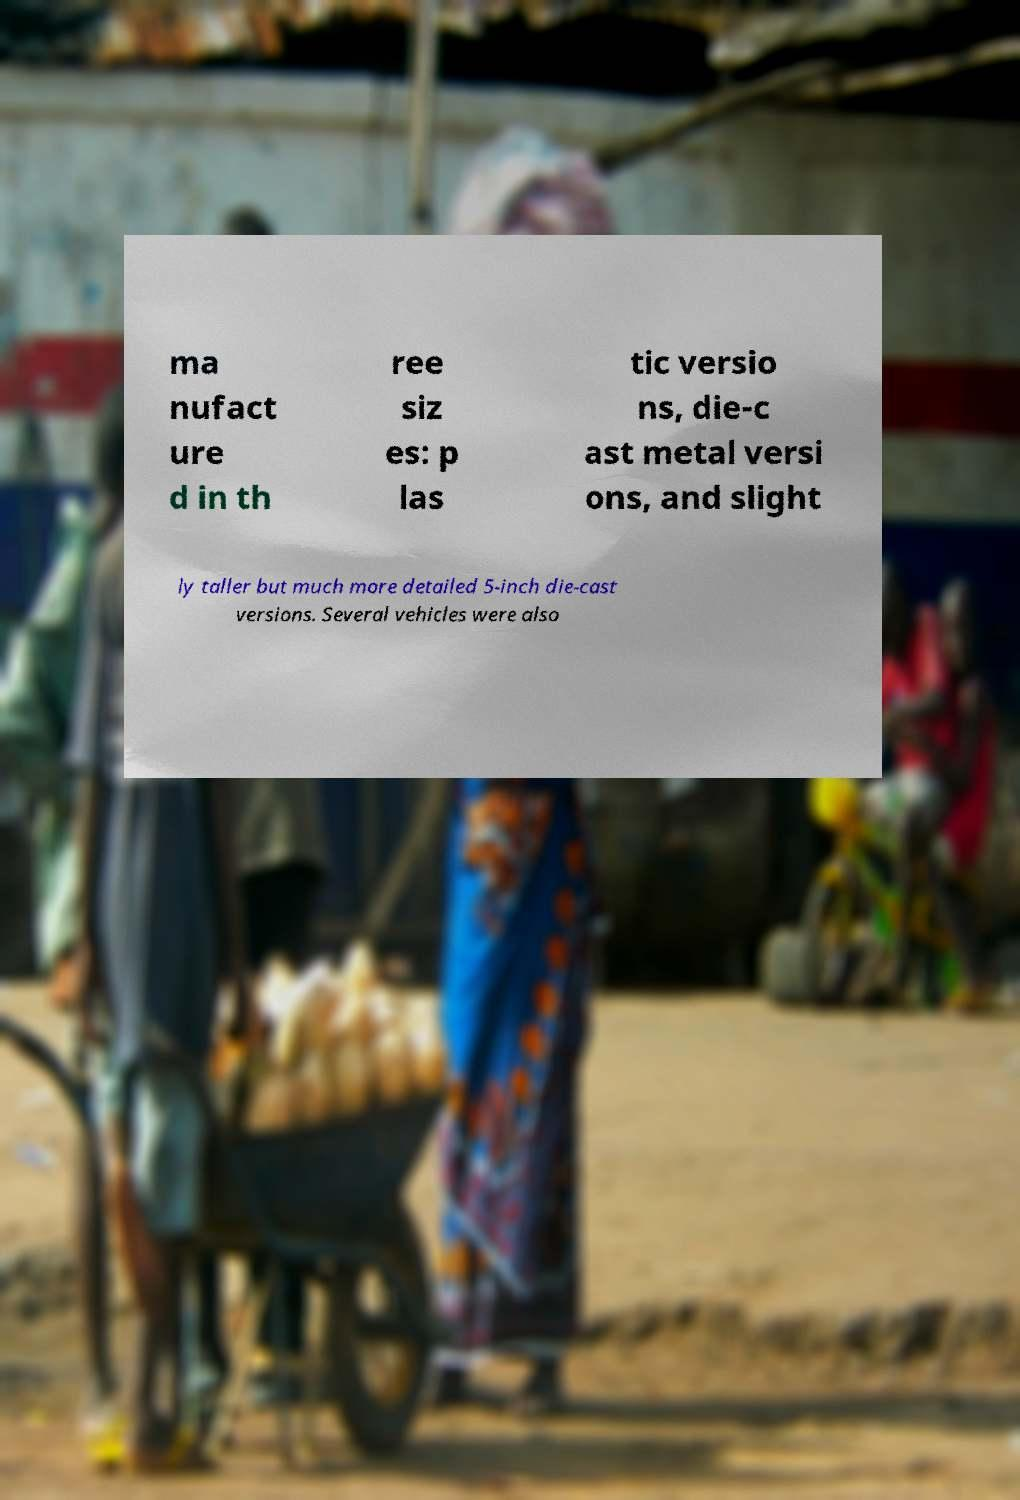Can you accurately transcribe the text from the provided image for me? ma nufact ure d in th ree siz es: p las tic versio ns, die-c ast metal versi ons, and slight ly taller but much more detailed 5-inch die-cast versions. Several vehicles were also 